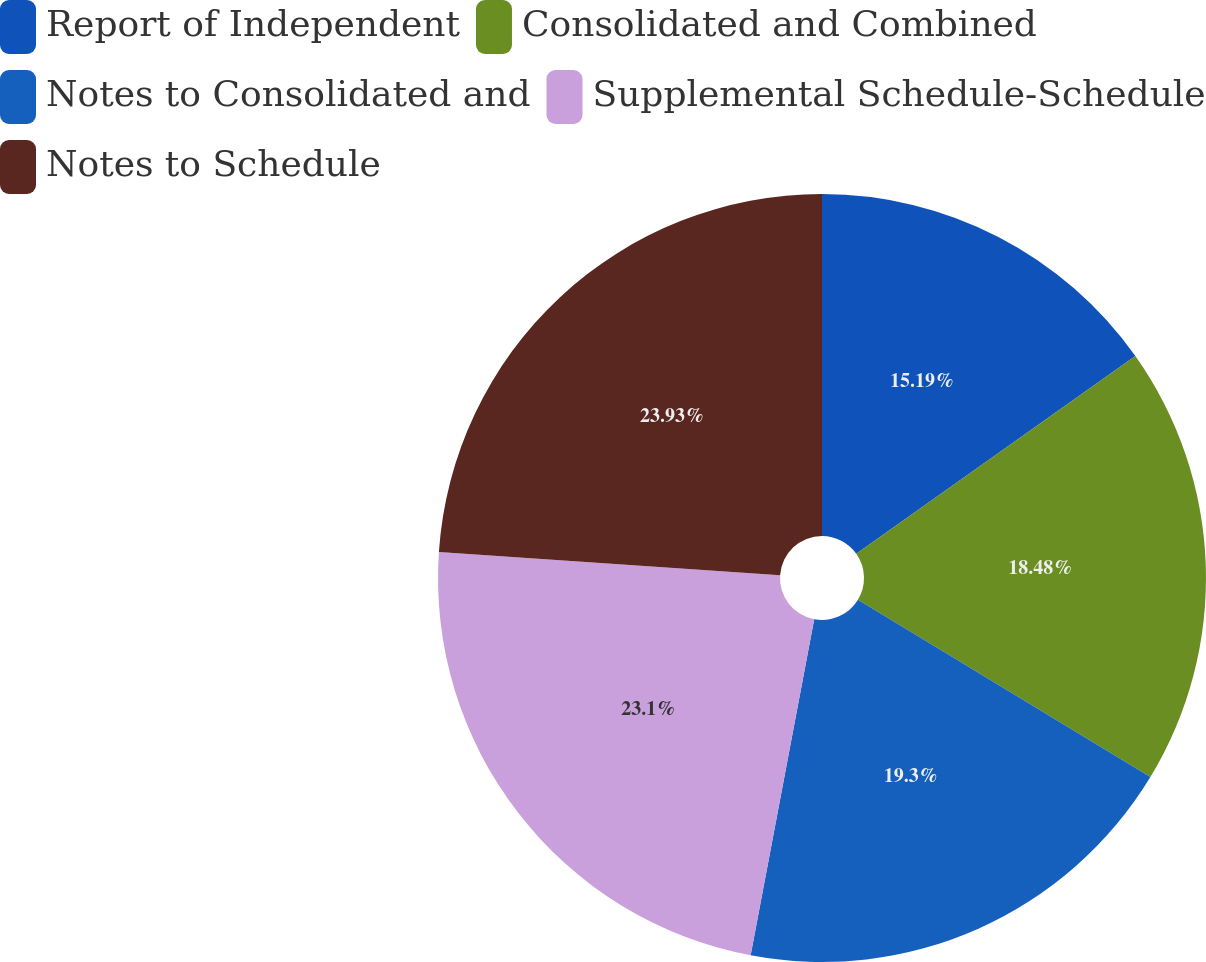Convert chart to OTSL. <chart><loc_0><loc_0><loc_500><loc_500><pie_chart><fcel>Report of Independent<fcel>Consolidated and Combined<fcel>Notes to Consolidated and<fcel>Supplemental Schedule-Schedule<fcel>Notes to Schedule<nl><fcel>15.19%<fcel>18.48%<fcel>19.3%<fcel>23.1%<fcel>23.92%<nl></chart> 